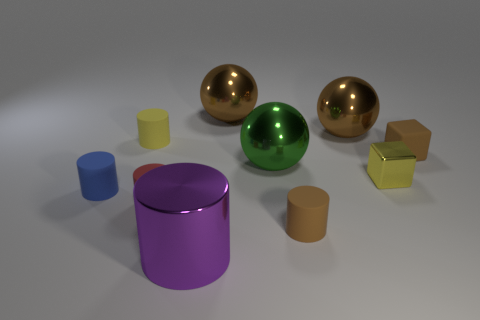Subtract all large brown spheres. How many spheres are left? 1 Subtract all brown cylinders. How many cylinders are left? 4 Subtract all cyan cubes. How many brown spheres are left? 2 Subtract 0 red balls. How many objects are left? 10 Subtract all blocks. How many objects are left? 8 Subtract 4 cylinders. How many cylinders are left? 1 Subtract all blue spheres. Subtract all blue blocks. How many spheres are left? 3 Subtract all tiny purple shiny blocks. Subtract all tiny yellow objects. How many objects are left? 8 Add 3 tiny yellow blocks. How many tiny yellow blocks are left? 4 Add 4 red cylinders. How many red cylinders exist? 5 